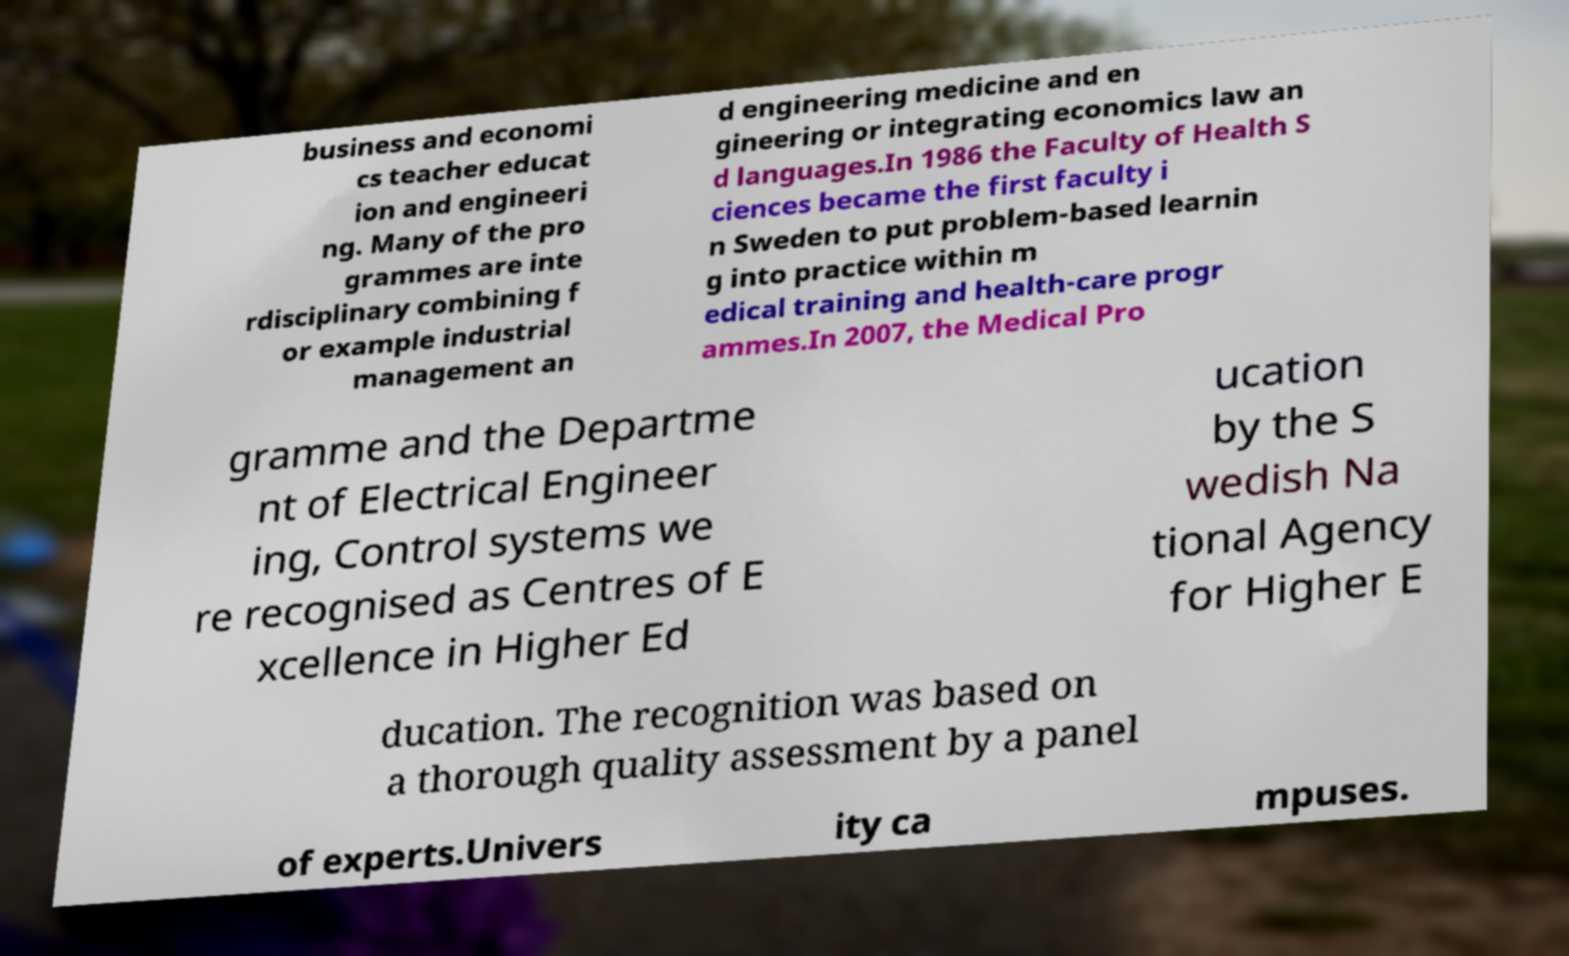Please read and relay the text visible in this image. What does it say? business and economi cs teacher educat ion and engineeri ng. Many of the pro grammes are inte rdisciplinary combining f or example industrial management an d engineering medicine and en gineering or integrating economics law an d languages.In 1986 the Faculty of Health S ciences became the first faculty i n Sweden to put problem-based learnin g into practice within m edical training and health-care progr ammes.In 2007, the Medical Pro gramme and the Departme nt of Electrical Engineer ing, Control systems we re recognised as Centres of E xcellence in Higher Ed ucation by the S wedish Na tional Agency for Higher E ducation. The recognition was based on a thorough quality assessment by a panel of experts.Univers ity ca mpuses. 